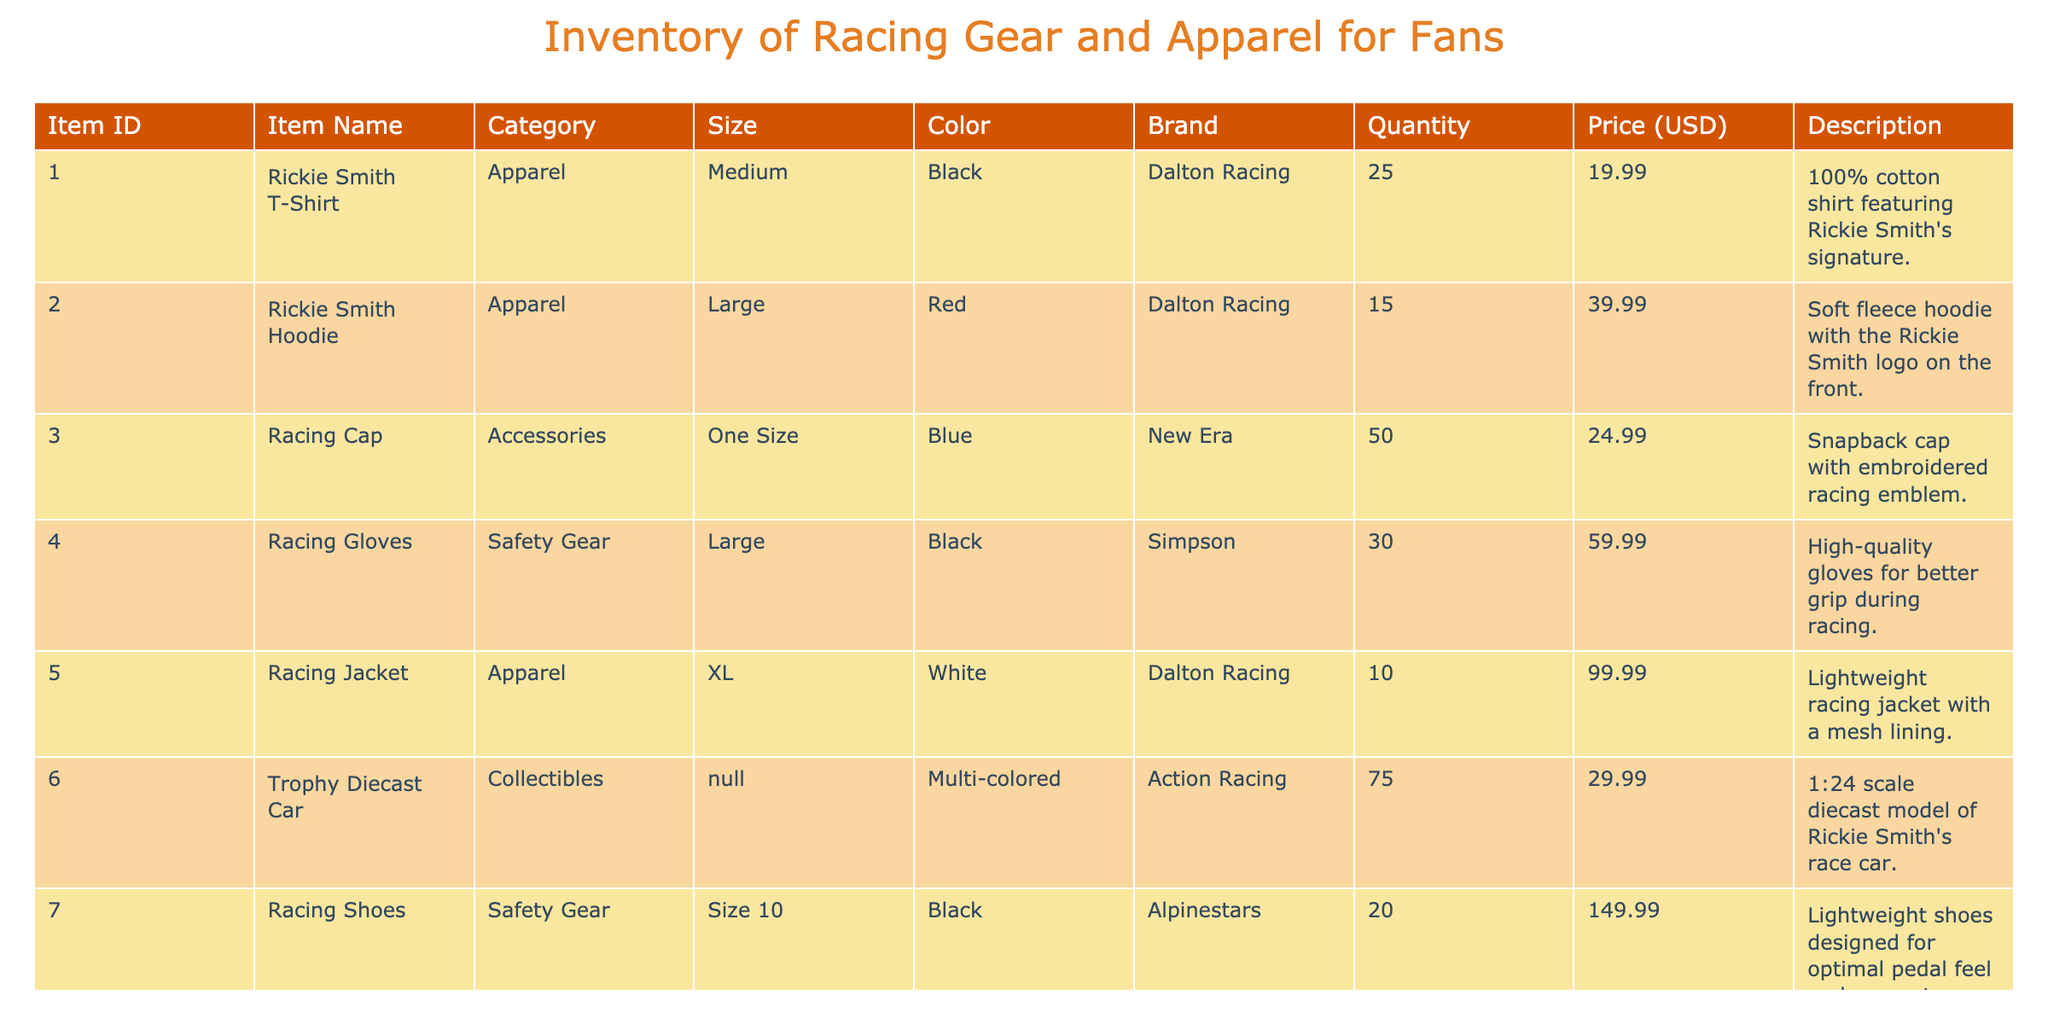What is the total number of Rickie Smith T-Shirts available? There are 25 Rickie Smith T-Shirts listed under the Quantity column for the Item ID 001.
Answer: 25 What is the price of the Racing Jacket? The Racing Jacket is listed at 99.99 USD in the Price column for the Item ID 005.
Answer: 99.99 Are there more Racing Caps or Racing Gloves in inventory? There are 50 Racing Caps (Item ID 003) and 30 Racing Gloves (Item ID 004). Since 50 > 30, there are more Racing Caps.
Answer: Yes, there are more Racing Caps What is the total quantity of Safety Gear items available? The Safety Gear items are Racing Gloves, Racing Shoes, and a Helmet. Their quantities are 30, 20, and 5, respectively. Summing these gives 30 + 20 + 5 = 55.
Answer: 55 What is the average price of the Collectibles? The collectibles are the Trophy Diecast Car and the Rickie Smith Autographed Poster, priced at 29.99 and 49.99 USD respectively. The average price is (29.99 + 49.99) / 2 = 39.99.
Answer: 39.99 Which item has the highest price, and what is that price? The item with the highest price is the Helmet at 299.99 USD (Item ID 010).
Answer: 299.99 Is there any item in the Accessories category with a price lower than 30 USD? The Racing Cap, listed under the Accessories category, has a price of 24.99 USD which is lower than 30.
Answer: Yes How many items are there in total for the 'Apparel' category? The Apparel category includes the Rickie Smith T-Shirt, Hoodie, and the Racing Jacket, with quantities of 25, 15, and 10 respectively. Adding them gives 25 + 15 + 10 = 50.
Answer: 50 What is the color of the Racing Shoes? The Racing Shoes, listed under the Safety Gear category (Item ID 007), are black in color.
Answer: Black 